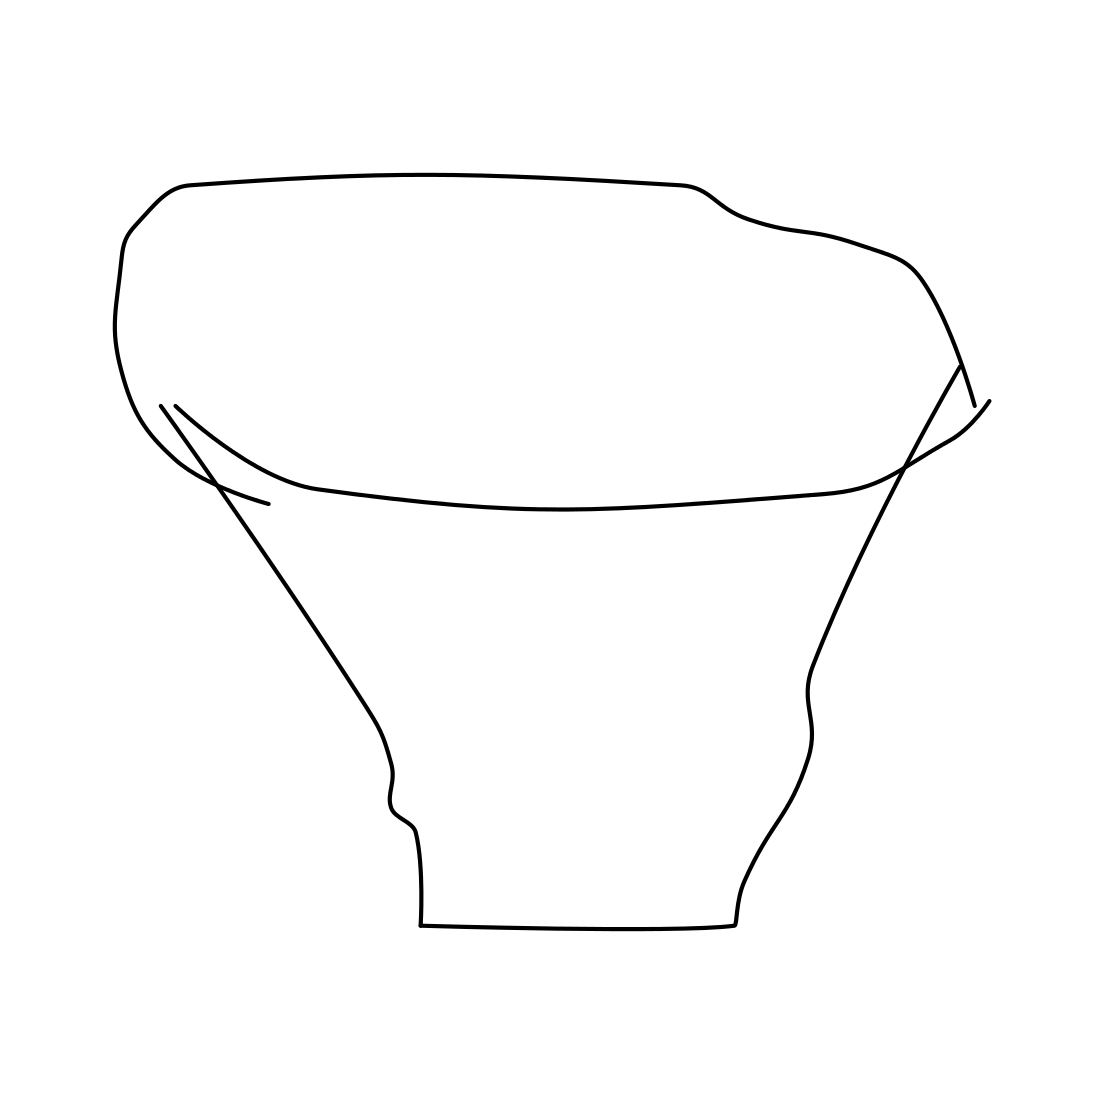Could you describe the style of this drawing? Certainly! The drawing is minimalist and abstract with clean lines, without shading or color. It emphasizes form and structure over detail, leaving much to the viewer's imagination about its texture or material. 